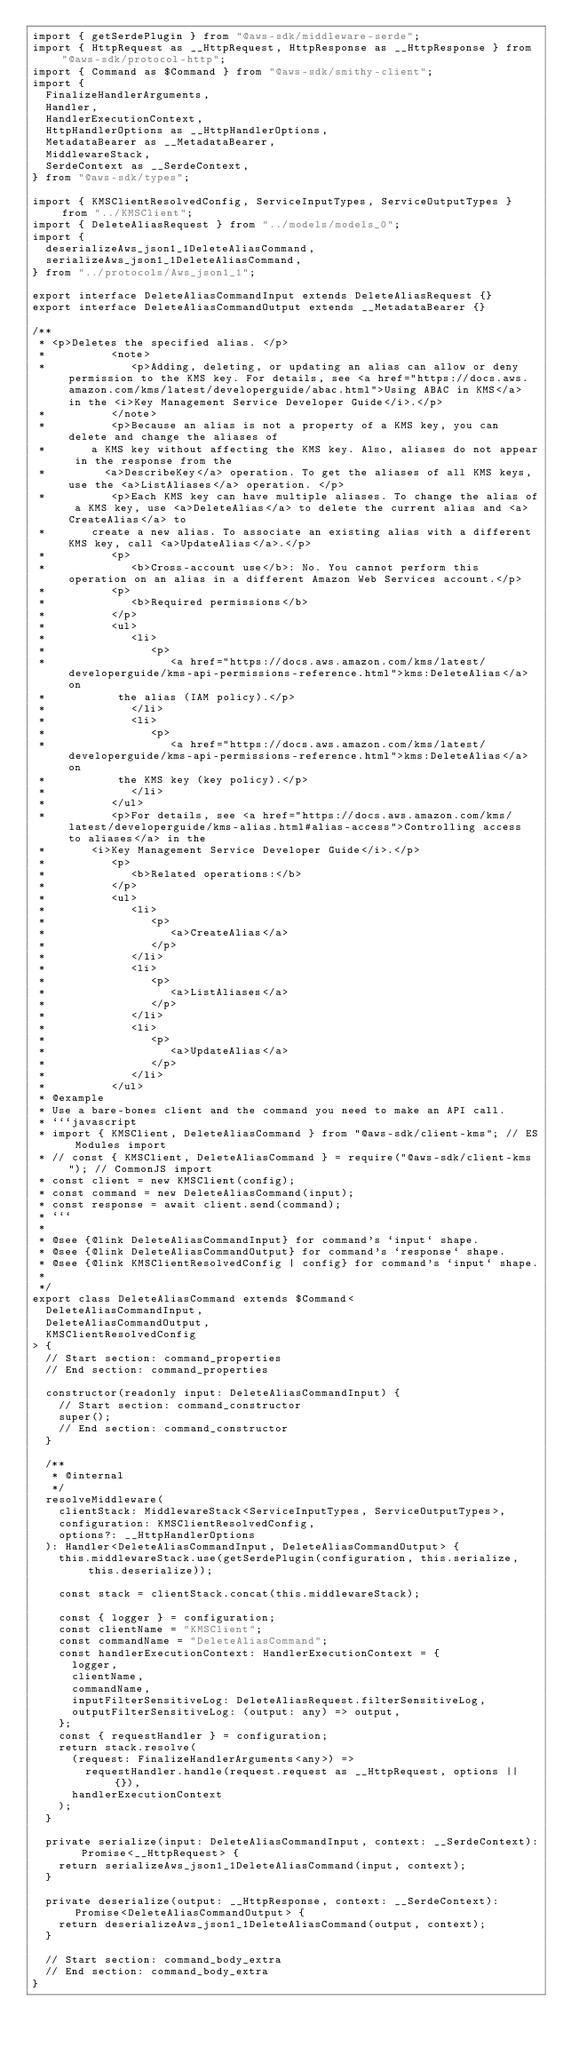<code> <loc_0><loc_0><loc_500><loc_500><_TypeScript_>import { getSerdePlugin } from "@aws-sdk/middleware-serde";
import { HttpRequest as __HttpRequest, HttpResponse as __HttpResponse } from "@aws-sdk/protocol-http";
import { Command as $Command } from "@aws-sdk/smithy-client";
import {
  FinalizeHandlerArguments,
  Handler,
  HandlerExecutionContext,
  HttpHandlerOptions as __HttpHandlerOptions,
  MetadataBearer as __MetadataBearer,
  MiddlewareStack,
  SerdeContext as __SerdeContext,
} from "@aws-sdk/types";

import { KMSClientResolvedConfig, ServiceInputTypes, ServiceOutputTypes } from "../KMSClient";
import { DeleteAliasRequest } from "../models/models_0";
import {
  deserializeAws_json1_1DeleteAliasCommand,
  serializeAws_json1_1DeleteAliasCommand,
} from "../protocols/Aws_json1_1";

export interface DeleteAliasCommandInput extends DeleteAliasRequest {}
export interface DeleteAliasCommandOutput extends __MetadataBearer {}

/**
 * <p>Deletes the specified alias. </p>
 *          <note>
 *             <p>Adding, deleting, or updating an alias can allow or deny permission to the KMS key. For details, see <a href="https://docs.aws.amazon.com/kms/latest/developerguide/abac.html">Using ABAC in KMS</a> in the <i>Key Management Service Developer Guide</i>.</p>
 *          </note>
 *          <p>Because an alias is not a property of a KMS key, you can delete and change the aliases of
 *       a KMS key without affecting the KMS key. Also, aliases do not appear in the response from the
 *         <a>DescribeKey</a> operation. To get the aliases of all KMS keys, use the <a>ListAliases</a> operation. </p>
 *          <p>Each KMS key can have multiple aliases. To change the alias of a KMS key, use <a>DeleteAlias</a> to delete the current alias and <a>CreateAlias</a> to
 *       create a new alias. To associate an existing alias with a different KMS key, call <a>UpdateAlias</a>.</p>
 *          <p>
 *             <b>Cross-account use</b>: No. You cannot perform this operation on an alias in a different Amazon Web Services account.</p>
 *          <p>
 *             <b>Required permissions</b>
 *          </p>
 *          <ul>
 *             <li>
 *                <p>
 *                   <a href="https://docs.aws.amazon.com/kms/latest/developerguide/kms-api-permissions-reference.html">kms:DeleteAlias</a> on
 *           the alias (IAM policy).</p>
 *             </li>
 *             <li>
 *                <p>
 *                   <a href="https://docs.aws.amazon.com/kms/latest/developerguide/kms-api-permissions-reference.html">kms:DeleteAlias</a> on
 *           the KMS key (key policy).</p>
 *             </li>
 *          </ul>
 *          <p>For details, see <a href="https://docs.aws.amazon.com/kms/latest/developerguide/kms-alias.html#alias-access">Controlling access to aliases</a> in the
 *       <i>Key Management Service Developer Guide</i>.</p>
 *          <p>
 *             <b>Related operations:</b>
 *          </p>
 *          <ul>
 *             <li>
 *                <p>
 *                   <a>CreateAlias</a>
 *                </p>
 *             </li>
 *             <li>
 *                <p>
 *                   <a>ListAliases</a>
 *                </p>
 *             </li>
 *             <li>
 *                <p>
 *                   <a>UpdateAlias</a>
 *                </p>
 *             </li>
 *          </ul>
 * @example
 * Use a bare-bones client and the command you need to make an API call.
 * ```javascript
 * import { KMSClient, DeleteAliasCommand } from "@aws-sdk/client-kms"; // ES Modules import
 * // const { KMSClient, DeleteAliasCommand } = require("@aws-sdk/client-kms"); // CommonJS import
 * const client = new KMSClient(config);
 * const command = new DeleteAliasCommand(input);
 * const response = await client.send(command);
 * ```
 *
 * @see {@link DeleteAliasCommandInput} for command's `input` shape.
 * @see {@link DeleteAliasCommandOutput} for command's `response` shape.
 * @see {@link KMSClientResolvedConfig | config} for command's `input` shape.
 *
 */
export class DeleteAliasCommand extends $Command<
  DeleteAliasCommandInput,
  DeleteAliasCommandOutput,
  KMSClientResolvedConfig
> {
  // Start section: command_properties
  // End section: command_properties

  constructor(readonly input: DeleteAliasCommandInput) {
    // Start section: command_constructor
    super();
    // End section: command_constructor
  }

  /**
   * @internal
   */
  resolveMiddleware(
    clientStack: MiddlewareStack<ServiceInputTypes, ServiceOutputTypes>,
    configuration: KMSClientResolvedConfig,
    options?: __HttpHandlerOptions
  ): Handler<DeleteAliasCommandInput, DeleteAliasCommandOutput> {
    this.middlewareStack.use(getSerdePlugin(configuration, this.serialize, this.deserialize));

    const stack = clientStack.concat(this.middlewareStack);

    const { logger } = configuration;
    const clientName = "KMSClient";
    const commandName = "DeleteAliasCommand";
    const handlerExecutionContext: HandlerExecutionContext = {
      logger,
      clientName,
      commandName,
      inputFilterSensitiveLog: DeleteAliasRequest.filterSensitiveLog,
      outputFilterSensitiveLog: (output: any) => output,
    };
    const { requestHandler } = configuration;
    return stack.resolve(
      (request: FinalizeHandlerArguments<any>) =>
        requestHandler.handle(request.request as __HttpRequest, options || {}),
      handlerExecutionContext
    );
  }

  private serialize(input: DeleteAliasCommandInput, context: __SerdeContext): Promise<__HttpRequest> {
    return serializeAws_json1_1DeleteAliasCommand(input, context);
  }

  private deserialize(output: __HttpResponse, context: __SerdeContext): Promise<DeleteAliasCommandOutput> {
    return deserializeAws_json1_1DeleteAliasCommand(output, context);
  }

  // Start section: command_body_extra
  // End section: command_body_extra
}
</code> 